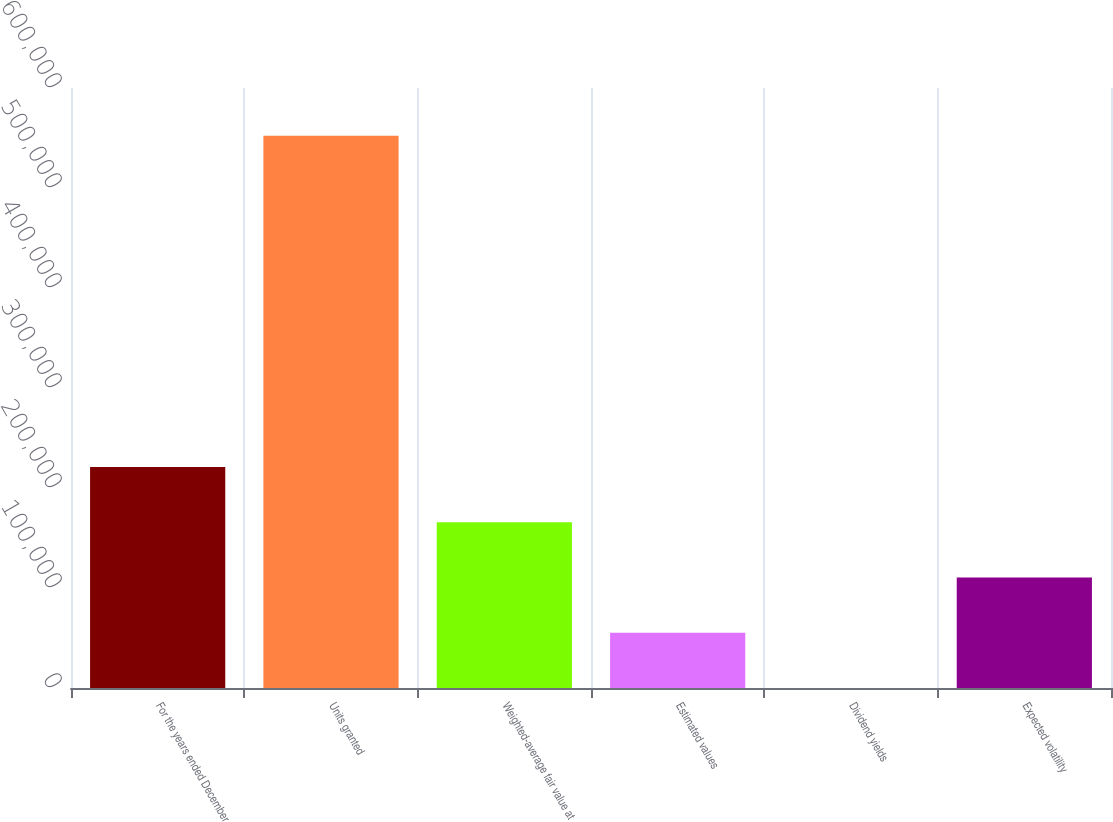Convert chart. <chart><loc_0><loc_0><loc_500><loc_500><bar_chart><fcel>For the years ended December<fcel>Units granted<fcel>Weighted-average fair value at<fcel>Estimated values<fcel>Dividend yields<fcel>Expected volatility<nl><fcel>220880<fcel>552195<fcel>165661<fcel>55222.5<fcel>3.3<fcel>110442<nl></chart> 